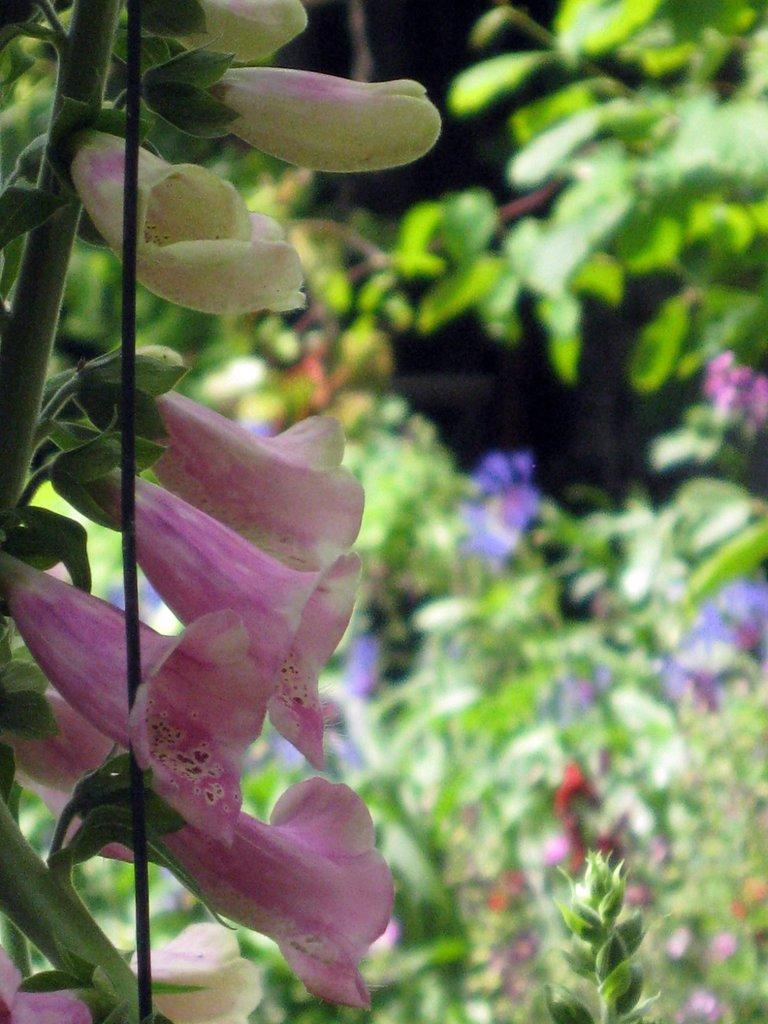What type of plant can be seen in the image? There is a flower plant in the image. What object is present alongside the flower plant? There is a stick in the image. What can be seen in the background of the image? The background of the image includes blurred views, plants, and flowers. Can you see your uncle waving in the background of the image? There is no person, including an uncle, present in the image. 